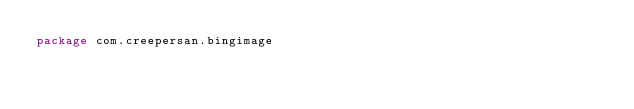<code> <loc_0><loc_0><loc_500><loc_500><_Kotlin_>package com.creepersan.bingimage

</code> 